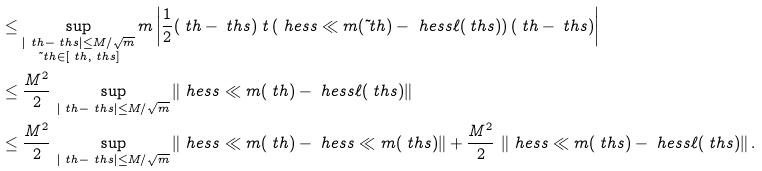Convert formula to latex. <formula><loc_0><loc_0><loc_500><loc_500>& \leq \sup _ { \substack { | \ t h - \ t h s | \leq { M } / \sqrt { m } \\ \tilde { \ } t h \in [ \ t h , \ t h s ] } } m \left | \frac { 1 } { 2 } ( \ t h - \ t h s ) \ t \left ( \ h e s s \ll m ( \tilde { \ } t h ) - \ h e s s \ell ( \ t h s ) \right ) ( \ t h - \ t h s ) \right | \\ & \leq \frac { M ^ { 2 } } { 2 } \, \sup _ { | \ t h - \ t h s | \leq { M } / \sqrt { m } } \left \| \ h e s s \ll m ( \ t h ) - \ h e s s \ell ( \ t h s ) \right \| \\ & \leq \frac { M ^ { 2 } } { 2 } \, \sup _ { | \ t h - \ t h s | \leq { M } / \sqrt { m } } \left \| \ h e s s \ll m ( \ t h ) - \ h e s s \ll m ( \ t h s ) \right \| + \frac { M ^ { 2 } } { 2 } \, \left \| \ h e s s \ll m ( \ t h s ) - \ h e s s \ell ( \ t h s ) \right \| . \\</formula> 